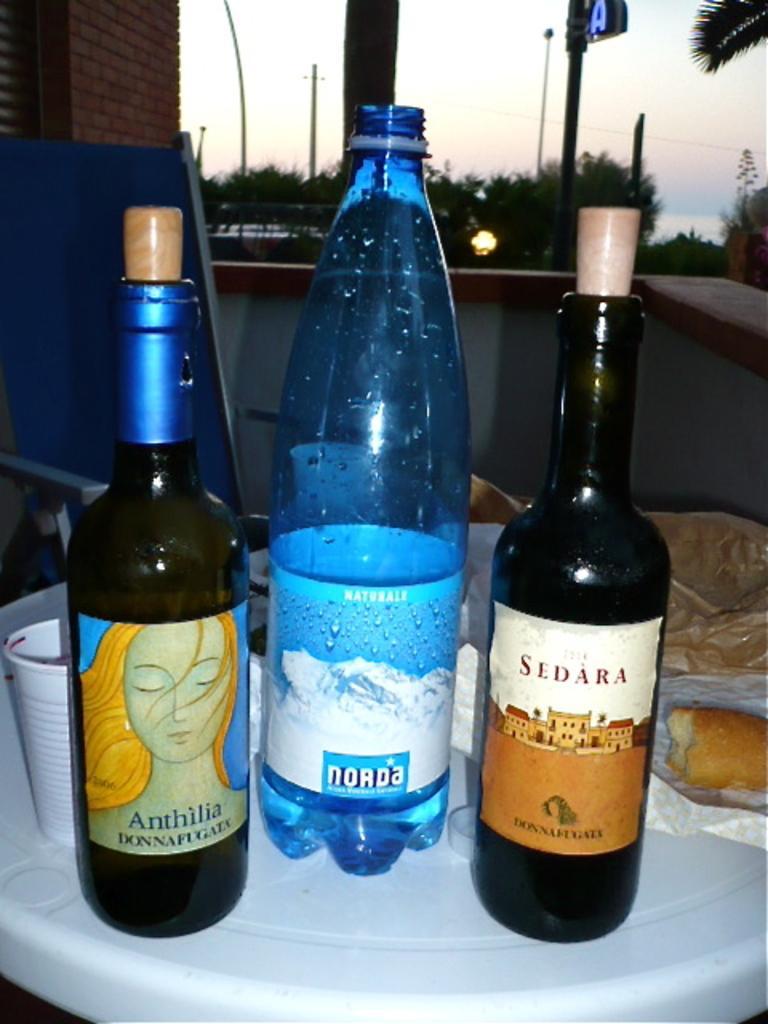Describe this image in one or two sentences. There is a table. There is a wine bottle,glass and water bottle on the table. We can see in the background there is a sky,trees,and some wall bricks. 